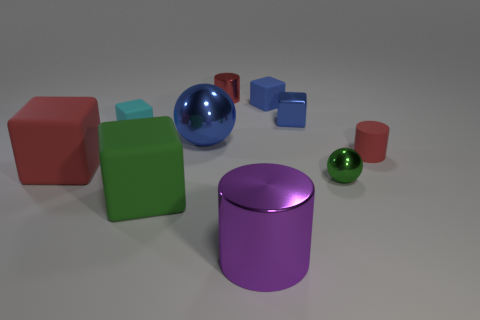Can you describe the colors and shapes of the objects in the image? Certainly! In the image, there are various objects with different shapes and colors. Starting with shapes, there are cubes, spheres, and a cylinder. As for colors, the cubes are red and green, the spheres are blue and green, while the cylinder is purple. There are also two smaller cubes, both of which are cyan. 